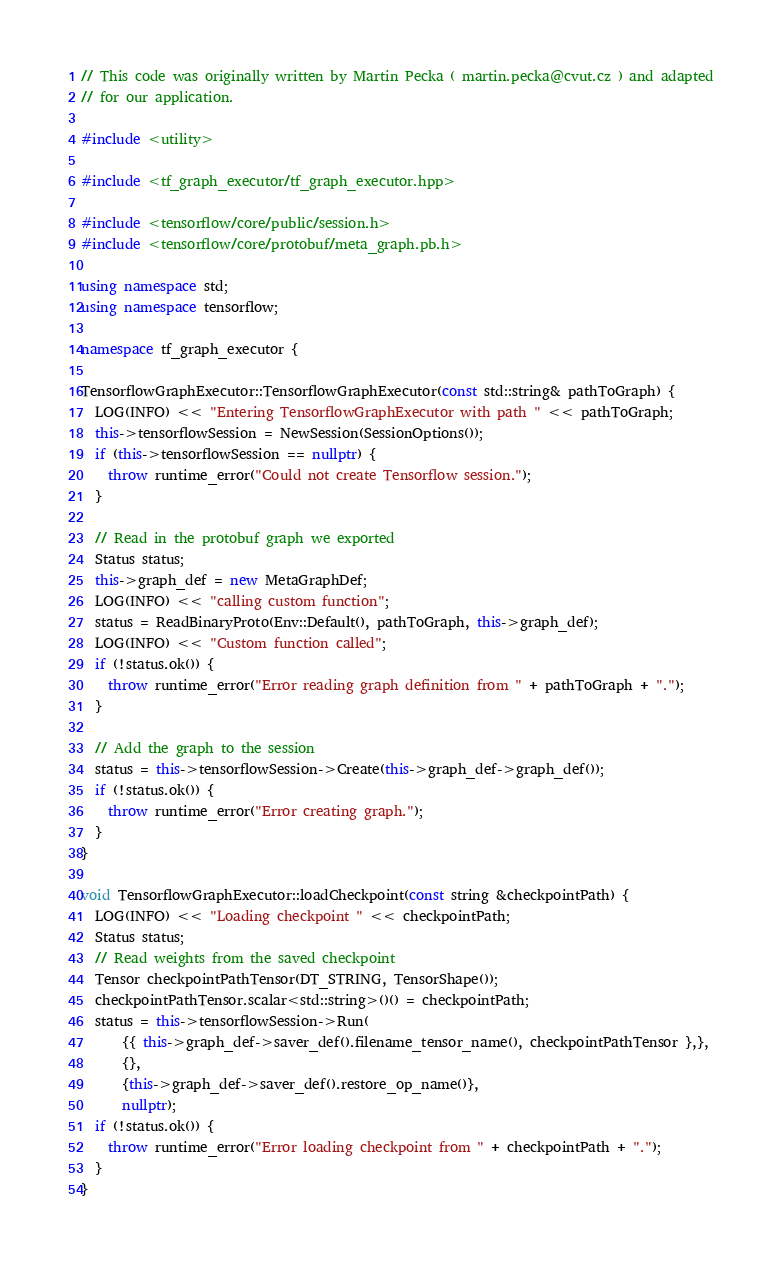Convert code to text. <code><loc_0><loc_0><loc_500><loc_500><_C++_>// This code was originally written by Martin Pecka ( martin.pecka@cvut.cz ) and adapted
// for our application.

#include <utility>

#include <tf_graph_executor/tf_graph_executor.hpp>

#include <tensorflow/core/public/session.h>
#include <tensorflow/core/protobuf/meta_graph.pb.h>

using namespace std;
using namespace tensorflow;

namespace tf_graph_executor {

TensorflowGraphExecutor::TensorflowGraphExecutor(const std::string& pathToGraph) {
  LOG(INFO) << "Entering TensorflowGraphExecutor with path " << pathToGraph;
  this->tensorflowSession = NewSession(SessionOptions());
  if (this->tensorflowSession == nullptr) {
    throw runtime_error("Could not create Tensorflow session.");
  }

  // Read in the protobuf graph we exported
  Status status;
  this->graph_def = new MetaGraphDef;
  LOG(INFO) << "calling custom function";
  status = ReadBinaryProto(Env::Default(), pathToGraph, this->graph_def);
  LOG(INFO) << "Custom function called";
  if (!status.ok()) {
    throw runtime_error("Error reading graph definition from " + pathToGraph + ".");
  }

  // Add the graph to the session
  status = this->tensorflowSession->Create(this->graph_def->graph_def());
  if (!status.ok()) {
    throw runtime_error("Error creating graph.");
  }
}

void TensorflowGraphExecutor::loadCheckpoint(const string &checkpointPath) {
  LOG(INFO) << "Loading checkpoint " << checkpointPath;
  Status status;
  // Read weights from the saved checkpoint
  Tensor checkpointPathTensor(DT_STRING, TensorShape());
  checkpointPathTensor.scalar<std::string>()() = checkpointPath;
  status = this->tensorflowSession->Run(
      {{ this->graph_def->saver_def().filename_tensor_name(), checkpointPathTensor },},
      {},
      {this->graph_def->saver_def().restore_op_name()},
      nullptr);
  if (!status.ok()) {
    throw runtime_error("Error loading checkpoint from " + checkpointPath + ".");
  }
}
</code> 